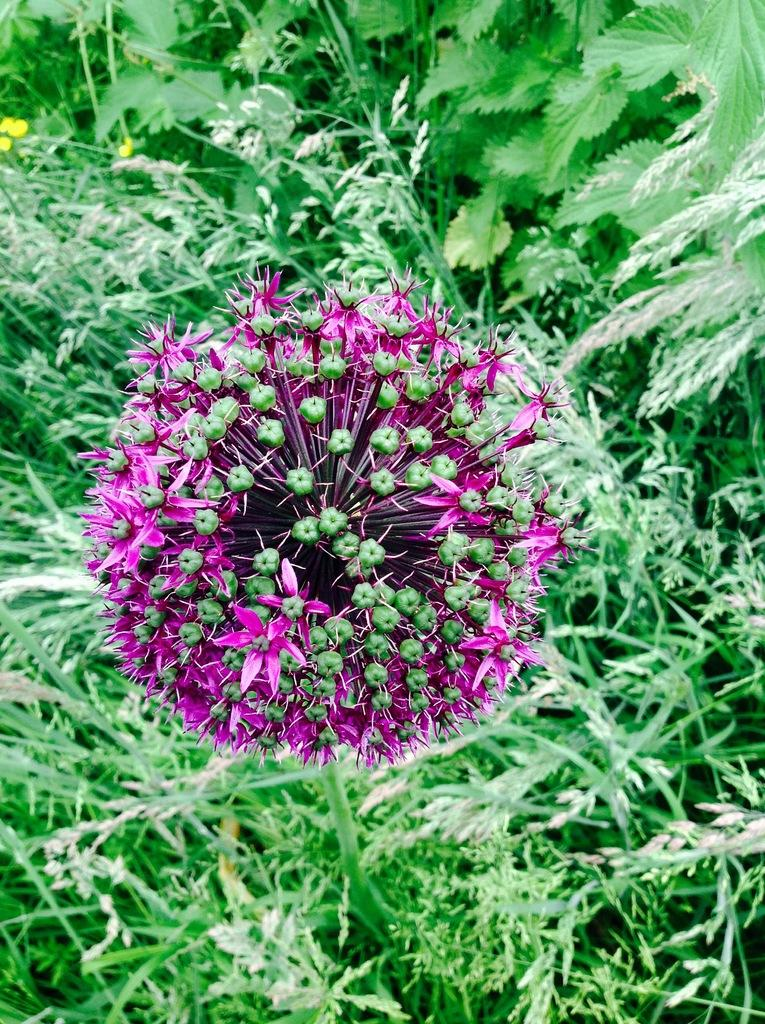What colors of flowers can be seen on the plants in the image? There are pink and yellow color flowers on the plants in the image. Can you describe the appearance of the pink flowers? The pink flowers are on a plant in the image. How about the yellow flowers? The yellow flowers are also on a plant in the image. What type of soap is being used to clean the quilt in the image? There is no soap or quilt present in the image; it only features pink and yellow flowers on plants. 